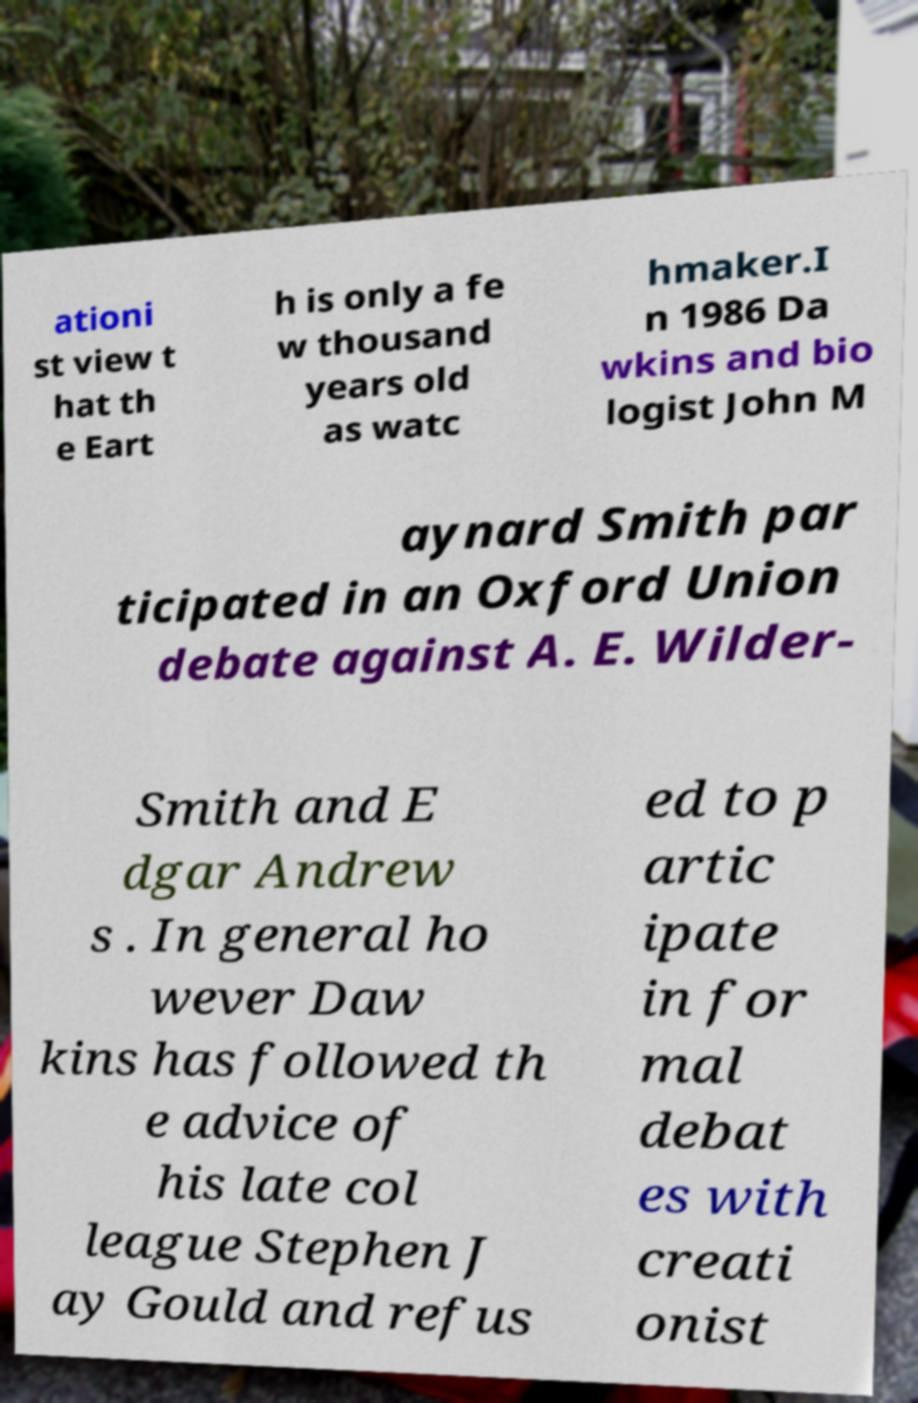Can you read and provide the text displayed in the image?This photo seems to have some interesting text. Can you extract and type it out for me? ationi st view t hat th e Eart h is only a fe w thousand years old as watc hmaker.I n 1986 Da wkins and bio logist John M aynard Smith par ticipated in an Oxford Union debate against A. E. Wilder- Smith and E dgar Andrew s . In general ho wever Daw kins has followed th e advice of his late col league Stephen J ay Gould and refus ed to p artic ipate in for mal debat es with creati onist 